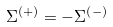Convert formula to latex. <formula><loc_0><loc_0><loc_500><loc_500>\Sigma ^ { \left ( + \right ) } = - \Sigma ^ { \left ( - \right ) }</formula> 